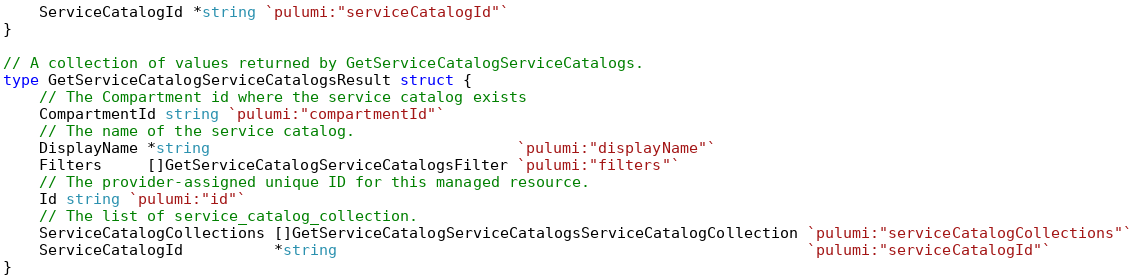Convert code to text. <code><loc_0><loc_0><loc_500><loc_500><_Go_>	ServiceCatalogId *string `pulumi:"serviceCatalogId"`
}

// A collection of values returned by GetServiceCatalogServiceCatalogs.
type GetServiceCatalogServiceCatalogsResult struct {
	// The Compartment id where the service catalog exists
	CompartmentId string `pulumi:"compartmentId"`
	// The name of the service catalog.
	DisplayName *string                                  `pulumi:"displayName"`
	Filters     []GetServiceCatalogServiceCatalogsFilter `pulumi:"filters"`
	// The provider-assigned unique ID for this managed resource.
	Id string `pulumi:"id"`
	// The list of service_catalog_collection.
	ServiceCatalogCollections []GetServiceCatalogServiceCatalogsServiceCatalogCollection `pulumi:"serviceCatalogCollections"`
	ServiceCatalogId          *string                                                    `pulumi:"serviceCatalogId"`
}
</code> 